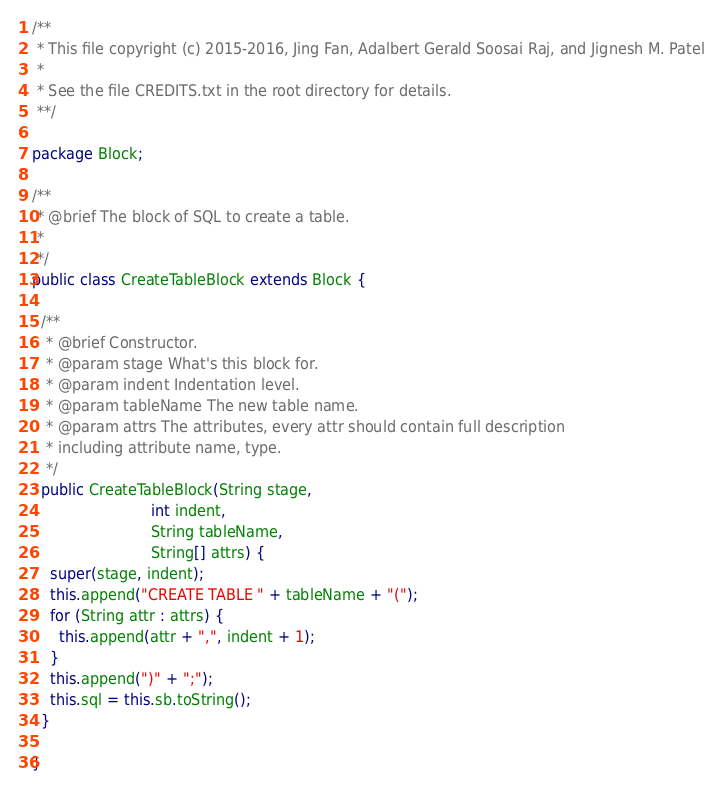<code> <loc_0><loc_0><loc_500><loc_500><_Java_>/**
 * This file copyright (c) 2015-2016, Jing Fan, Adalbert Gerald Soosai Raj, and Jignesh M. Patel
 *
 * See the file CREDITS.txt in the root directory for details.
 **/

package Block;

/**
 * @brief The block of SQL to create a table.
 *
 */
public class CreateTableBlock extends Block {

  /**
   * @brief Constructor.
   * @param stage What's this block for.
   * @param indent Indentation level.
   * @param tableName The new table name.
   * @param attrs The attributes, every attr should contain full description
   * including attribute name, type.
   */
  public CreateTableBlock(String stage,
                          int indent,
                          String tableName,
                          String[] attrs) {
    super(stage, indent);
    this.append("CREATE TABLE " + tableName + "(");
    for (String attr : attrs) {
      this.append(attr + ",", indent + 1);
    }
    this.append(")" + ";");
    this.sql = this.sb.toString();
  }

}
</code> 